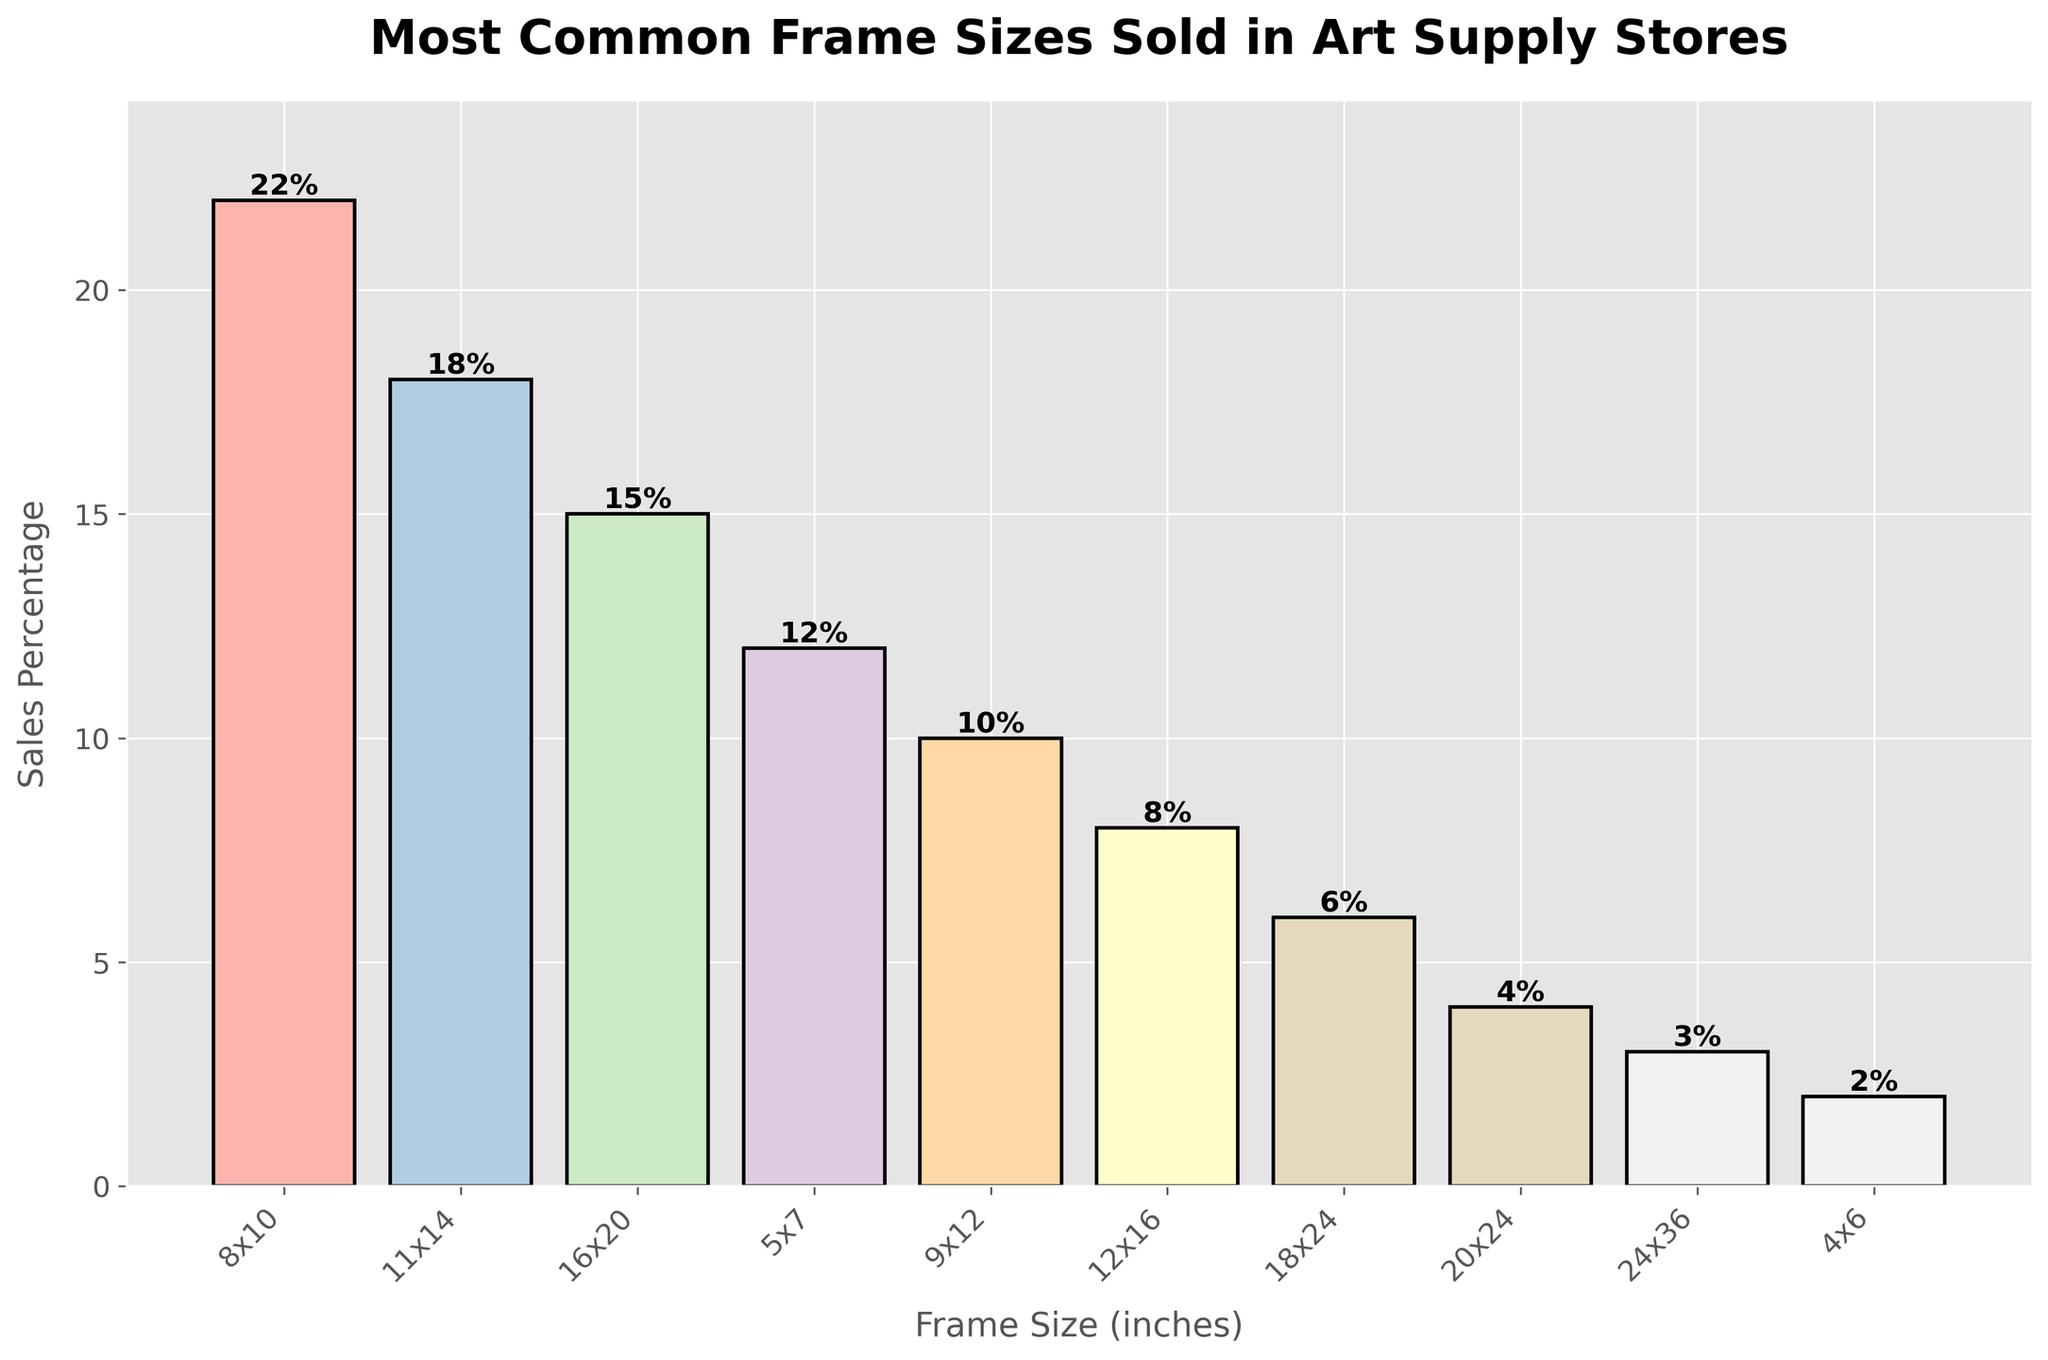What's the most common frame size sold? Based on the bar chart, the frame size with the highest sales percentage is the most common. The 8x10 size has the highest bar which represents 22%.
Answer: 8x10 What is the total sales percentage for frames with dimensions above 18x24? Identify the individual sales percentages of frames larger than 18x24, which are 20x24 (4%) and 24x36 (3%). Adding them together, the total is 4% + 3% = 7%.
Answer: 7% Which frame size has the lowest sales percentage? The frame size with the smallest percentage bar is the 4x6 size, representing 2%.
Answer: 4x6 How much higher is the sales percentage of the most common frame size compared to the least common frame size? The most common frame size (8x10) has a sales percentage of 22%, and the least common (4x6) has 2%. The difference is 22% - 2% = 20%.
Answer: 20% What is the median sales percentage of the frame sizes? First, list the sales percentages in ascending order: 2, 3, 4, 6, 8, 10, 12, 15, 18, 22. The median is the average of the 5th and 6th values: (8 + 10) / 2 = 9%.
Answer: 9% Which frame size between 12x16 and 16x20 has a higher sales percentage, and by how much? The sales percentage for 16x20 is 15%, and for 12x16, it is 8%. The difference is 15% - 8% = 7%.
Answer: 16x20, 7% What percentage of sales are from frame sizes smaller than 9x12? Frame sizes smaller than 9x12 are 8x10 (22%), 5x7 (12%), and 4x6 (2%). Summing these percentages gives 22% + 12% + 2% = 36%.
Answer: 36% What is the difference in sales percentage between the second most common and the third most common frame sizes? The second most common frame size, 11x14, has an 18% sales percentage. The third most common, 16x20, has a 15% sales percentage. The difference is 18% - 15% = 3%.
Answer: 3% List the frame sizes that have a sales percentage of 10% or above. The frame sizes with sales percentages of 10% or above are listed: 8x10 (22%), 11x14 (18%), 16x20 (15%), 5x7 (12%), and 9x12 (10%).
Answer: 8x10, 11x14, 16x20, 5x7, 9x12 How do the sales percentages of 9x12 and 18x24 compare visually in the chart? Visually, the bar for 9x12 is taller than that for 18x24. The height difference corresponds to their sales percentages: 10% for 9x12 versus 6% for 18x24. Thus, 9x12 has a higher sales percentage.
Answer: 9x12 is higher 